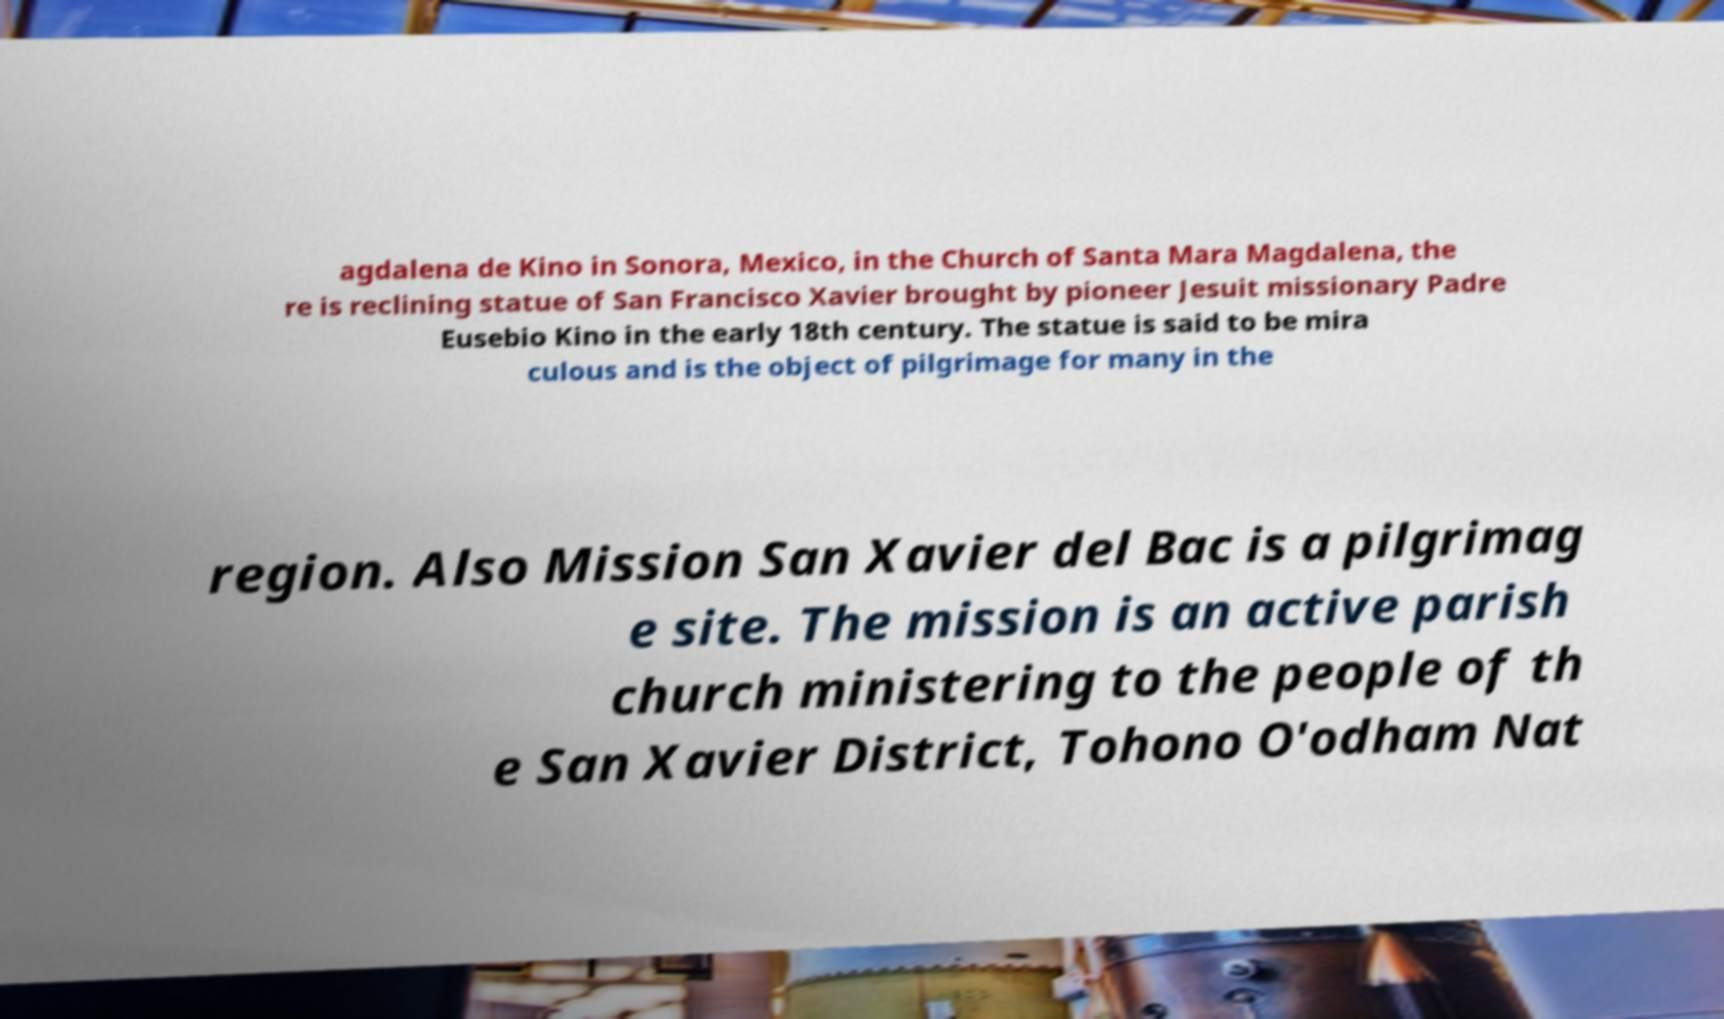Can you read and provide the text displayed in the image?This photo seems to have some interesting text. Can you extract and type it out for me? agdalena de Kino in Sonora, Mexico, in the Church of Santa Mara Magdalena, the re is reclining statue of San Francisco Xavier brought by pioneer Jesuit missionary Padre Eusebio Kino in the early 18th century. The statue is said to be mira culous and is the object of pilgrimage for many in the region. Also Mission San Xavier del Bac is a pilgrimag e site. The mission is an active parish church ministering to the people of th e San Xavier District, Tohono O'odham Nat 